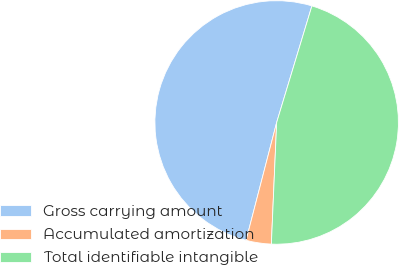Convert chart to OTSL. <chart><loc_0><loc_0><loc_500><loc_500><pie_chart><fcel>Gross carrying amount<fcel>Accumulated amortization<fcel>Total identifiable intangible<nl><fcel>50.63%<fcel>3.35%<fcel>46.02%<nl></chart> 